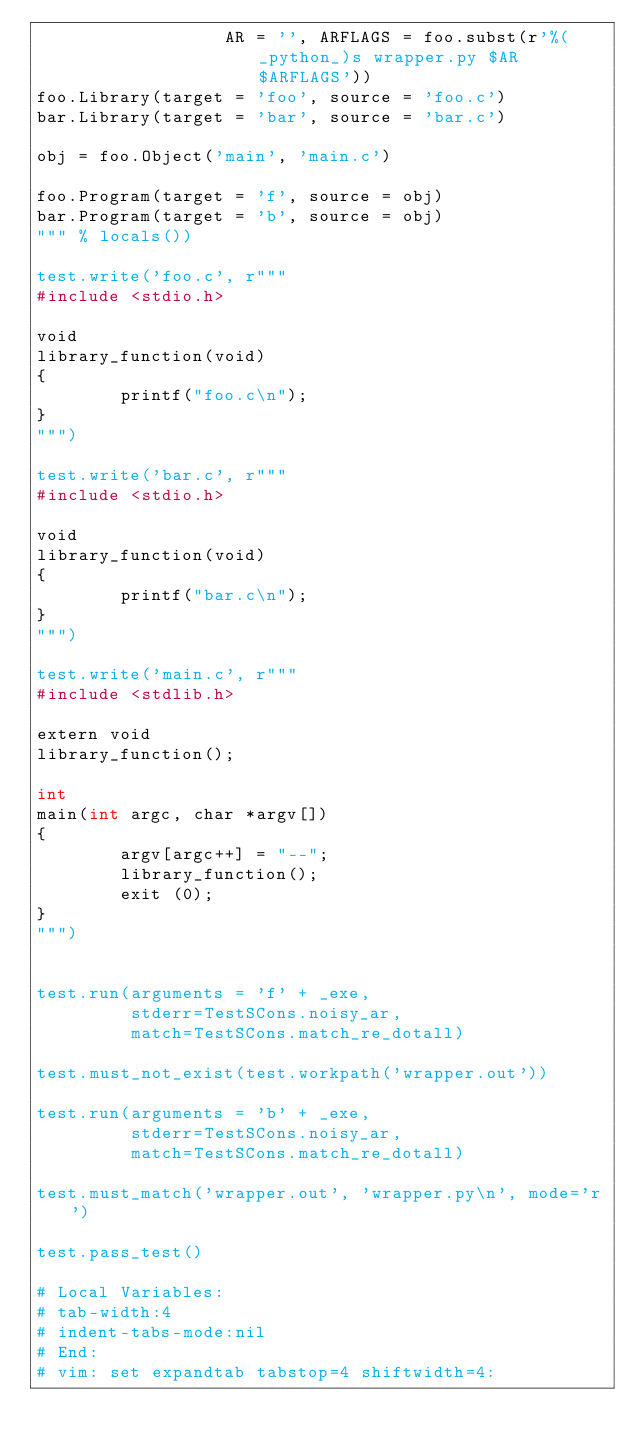<code> <loc_0><loc_0><loc_500><loc_500><_Python_>                  AR = '', ARFLAGS = foo.subst(r'%(_python_)s wrapper.py $AR $ARFLAGS'))
foo.Library(target = 'foo', source = 'foo.c')
bar.Library(target = 'bar', source = 'bar.c')

obj = foo.Object('main', 'main.c')

foo.Program(target = 'f', source = obj)
bar.Program(target = 'b', source = obj)
""" % locals())

test.write('foo.c', r"""
#include <stdio.h>

void
library_function(void)
{
        printf("foo.c\n");
}
""")

test.write('bar.c', r"""
#include <stdio.h>

void
library_function(void)
{
        printf("bar.c\n");
}
""")

test.write('main.c', r"""
#include <stdlib.h>

extern void
library_function();

int
main(int argc, char *argv[])
{
        argv[argc++] = "--";
        library_function();
        exit (0);
}
""")


test.run(arguments = 'f' + _exe,
         stderr=TestSCons.noisy_ar,
         match=TestSCons.match_re_dotall)

test.must_not_exist(test.workpath('wrapper.out'))

test.run(arguments = 'b' + _exe,
         stderr=TestSCons.noisy_ar,
         match=TestSCons.match_re_dotall)

test.must_match('wrapper.out', 'wrapper.py\n', mode='r')

test.pass_test()

# Local Variables:
# tab-width:4
# indent-tabs-mode:nil
# End:
# vim: set expandtab tabstop=4 shiftwidth=4:
</code> 